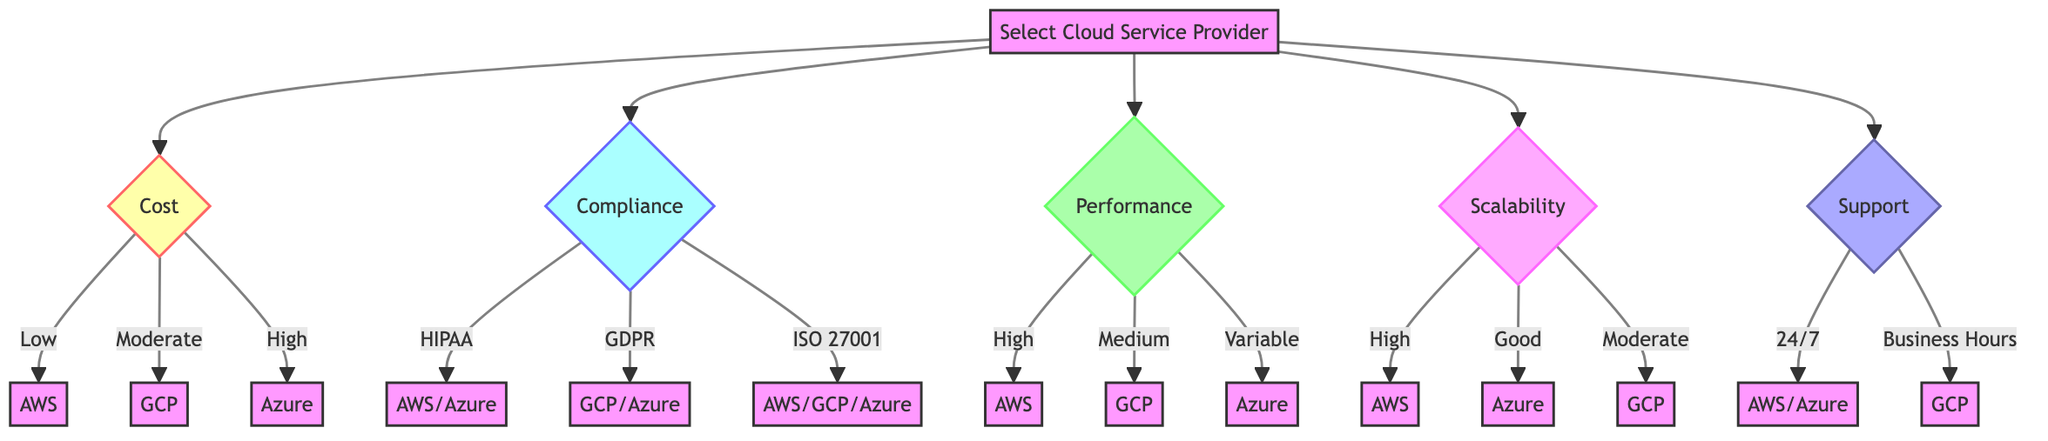What is the primary objective of the decision-making framework? The diagram's top node clearly states that the objective is to "Select the optimal cloud service provider," which is explicitly mentioned under the DecisionMakingFramework section.
Answer: Select the optimal cloud service provider How many criteria are listed in the decision-making framework? The diagram breaks down the decision-making framework into five distinct criteria: Cost, Compliance, Performance, Scalability, and Support. Counting these gives a total of five criteria.
Answer: Five Which cloud service providers are listed under the Low Cost option? The diagram provides a direct link from the Cost criterion showing that "Amazon Web Services (AWS)" is the sole provider listed under the Low Cost option.
Answer: Amazon Web Services (AWS) What is the cloud service provider that offers High Scalability? From the Scalability criterion in the diagram, it indicates that "Amazon Web Services (AWS)" is identified as the provider offering High Scalability.
Answer: Amazon Web Services (AWS) If compliance with GDPR is required, which cloud providers can be chosen? Following the Compliance criterion, the diagram indicates that "Google Cloud Platform (GCP)" and "Microsoft Azure" are the providers compliant with GDPR, thereby allowing these two options.
Answer: Google Cloud Platform (GCP), Microsoft Azure Which cloud service provider has Business Hours Support? The Support criterion outlines that only "Google Cloud Platform (GCP)" offers Business Hours Support, making it the sole provider in that category.
Answer: Google Cloud Platform (GCP) If a user needs a provider with both HIPAA compliance and 24/7 support, which providers qualify? By analyzing both criteria, HIPAA compliance allows "AWS" and "Microsoft Azure," while 24/7 support includes "AWS" and "Microsoft Azure" again. Thus, both providers qualify, leading to the conclusion.
Answer: Amazon Web Services (AWS), Microsoft Azure Which provider is noted for Variable Performance? From the Performance criterion, it is stated that "Microsoft Azure" is categorized under Variable Performance, making it the provider for that specific need.
Answer: Microsoft Azure What criterion has the highest number of options listed? Upon examination, the Compliance criterion has three distinct options (HIPAA, GDPR, ISO 27001) with multiple providers under each, making it the criterion with the highest number of options.
Answer: Compliance 